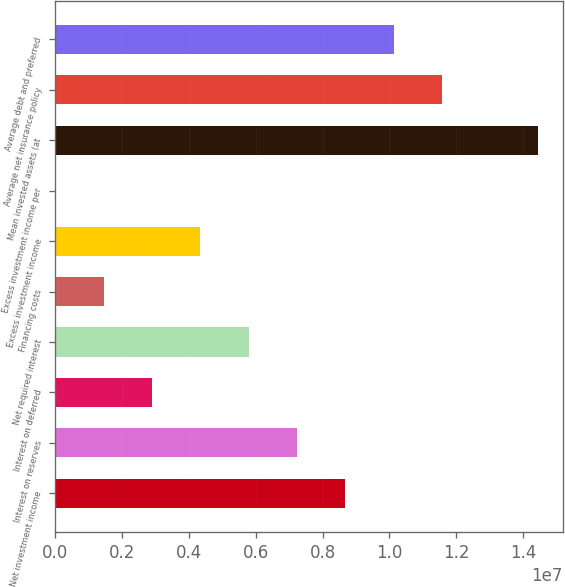Convert chart. <chart><loc_0><loc_0><loc_500><loc_500><bar_chart><fcel>Net investment income<fcel>Interest on reserves<fcel>Interest on deferred<fcel>Net required interest<fcel>Financing costs<fcel>Excess investment income<fcel>Excess investment income per<fcel>Mean invested assets (at<fcel>Average net insurance policy<fcel>Average debt and preferred<nl><fcel>8.6769e+06<fcel>7.23075e+06<fcel>2.8923e+06<fcel>5.7846e+06<fcel>1.44615e+06<fcel>4.33845e+06<fcel>1.83<fcel>1.44615e+07<fcel>1.15692e+07<fcel>1.01231e+07<nl></chart> 